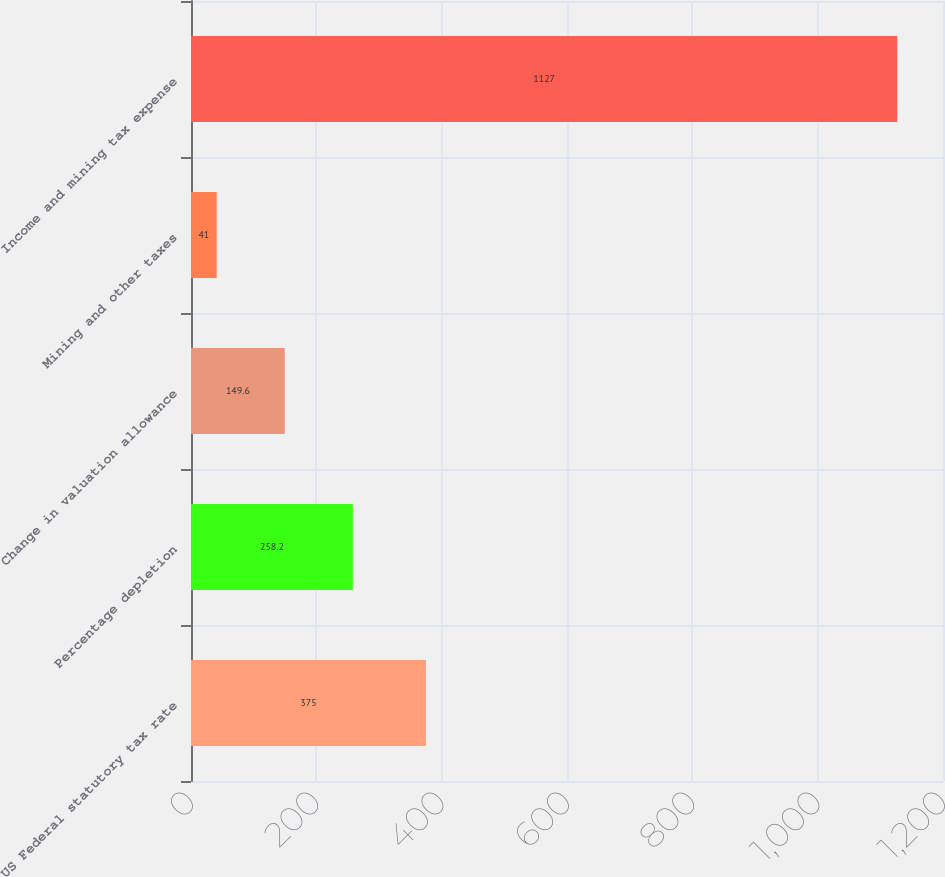Convert chart. <chart><loc_0><loc_0><loc_500><loc_500><bar_chart><fcel>US Federal statutory tax rate<fcel>Percentage depletion<fcel>Change in valuation allowance<fcel>Mining and other taxes<fcel>Income and mining tax expense<nl><fcel>375<fcel>258.2<fcel>149.6<fcel>41<fcel>1127<nl></chart> 